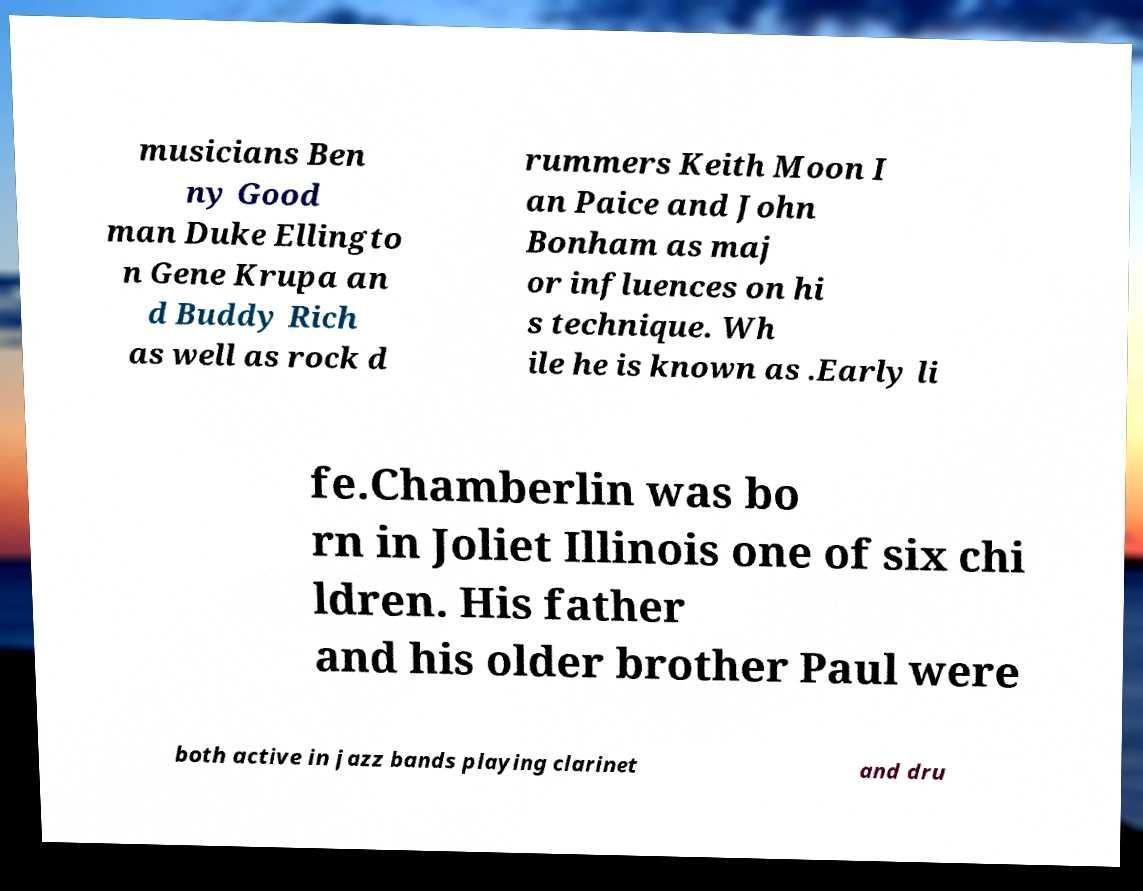Could you assist in decoding the text presented in this image and type it out clearly? musicians Ben ny Good man Duke Ellingto n Gene Krupa an d Buddy Rich as well as rock d rummers Keith Moon I an Paice and John Bonham as maj or influences on hi s technique. Wh ile he is known as .Early li fe.Chamberlin was bo rn in Joliet Illinois one of six chi ldren. His father and his older brother Paul were both active in jazz bands playing clarinet and dru 